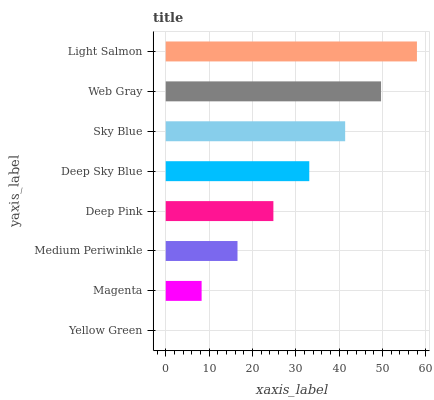Is Yellow Green the minimum?
Answer yes or no. Yes. Is Light Salmon the maximum?
Answer yes or no. Yes. Is Magenta the minimum?
Answer yes or no. No. Is Magenta the maximum?
Answer yes or no. No. Is Magenta greater than Yellow Green?
Answer yes or no. Yes. Is Yellow Green less than Magenta?
Answer yes or no. Yes. Is Yellow Green greater than Magenta?
Answer yes or no. No. Is Magenta less than Yellow Green?
Answer yes or no. No. Is Deep Sky Blue the high median?
Answer yes or no. Yes. Is Deep Pink the low median?
Answer yes or no. Yes. Is Yellow Green the high median?
Answer yes or no. No. Is Web Gray the low median?
Answer yes or no. No. 